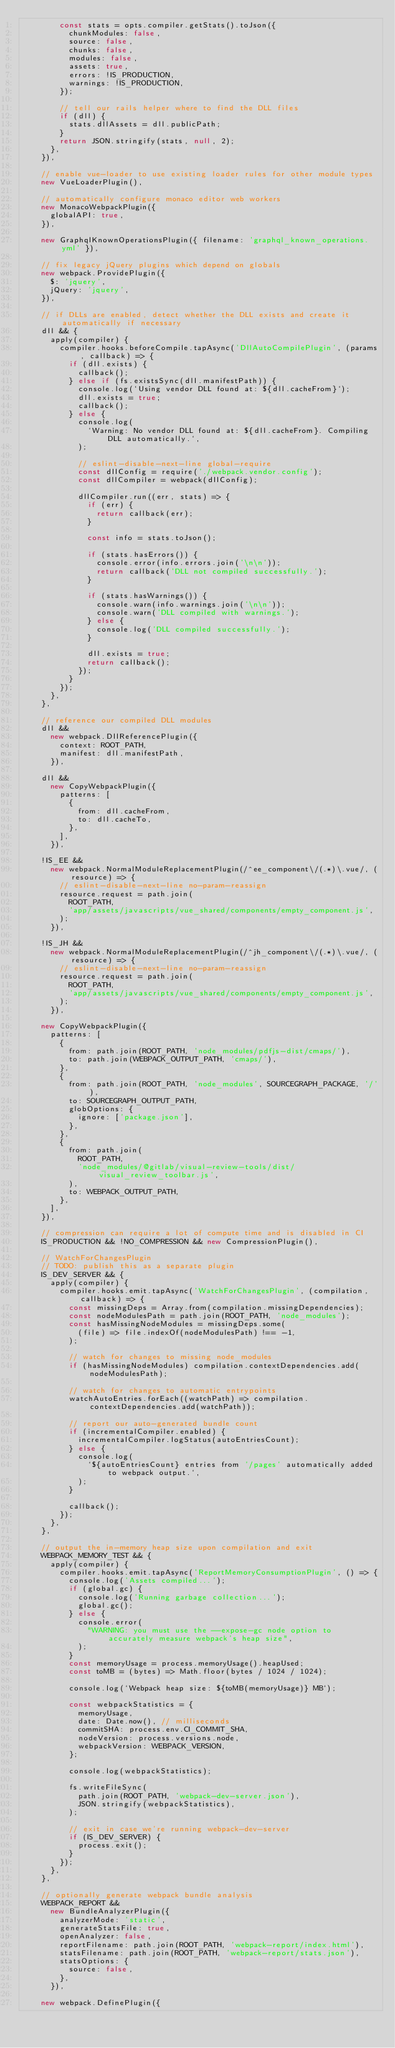Convert code to text. <code><loc_0><loc_0><loc_500><loc_500><_JavaScript_>        const stats = opts.compiler.getStats().toJson({
          chunkModules: false,
          source: false,
          chunks: false,
          modules: false,
          assets: true,
          errors: !IS_PRODUCTION,
          warnings: !IS_PRODUCTION,
        });

        // tell our rails helper where to find the DLL files
        if (dll) {
          stats.dllAssets = dll.publicPath;
        }
        return JSON.stringify(stats, null, 2);
      },
    }),

    // enable vue-loader to use existing loader rules for other module types
    new VueLoaderPlugin(),

    // automatically configure monaco editor web workers
    new MonacoWebpackPlugin({
      globalAPI: true,
    }),

    new GraphqlKnownOperationsPlugin({ filename: 'graphql_known_operations.yml' }),

    // fix legacy jQuery plugins which depend on globals
    new webpack.ProvidePlugin({
      $: 'jquery',
      jQuery: 'jquery',
    }),

    // if DLLs are enabled, detect whether the DLL exists and create it automatically if necessary
    dll && {
      apply(compiler) {
        compiler.hooks.beforeCompile.tapAsync('DllAutoCompilePlugin', (params, callback) => {
          if (dll.exists) {
            callback();
          } else if (fs.existsSync(dll.manifestPath)) {
            console.log(`Using vendor DLL found at: ${dll.cacheFrom}`);
            dll.exists = true;
            callback();
          } else {
            console.log(
              `Warning: No vendor DLL found at: ${dll.cacheFrom}. Compiling DLL automatically.`,
            );

            // eslint-disable-next-line global-require
            const dllConfig = require('./webpack.vendor.config');
            const dllCompiler = webpack(dllConfig);

            dllCompiler.run((err, stats) => {
              if (err) {
                return callback(err);
              }

              const info = stats.toJson();

              if (stats.hasErrors()) {
                console.error(info.errors.join('\n\n'));
                return callback('DLL not compiled successfully.');
              }

              if (stats.hasWarnings()) {
                console.warn(info.warnings.join('\n\n'));
                console.warn('DLL compiled with warnings.');
              } else {
                console.log('DLL compiled successfully.');
              }

              dll.exists = true;
              return callback();
            });
          }
        });
      },
    },

    // reference our compiled DLL modules
    dll &&
      new webpack.DllReferencePlugin({
        context: ROOT_PATH,
        manifest: dll.manifestPath,
      }),

    dll &&
      new CopyWebpackPlugin({
        patterns: [
          {
            from: dll.cacheFrom,
            to: dll.cacheTo,
          },
        ],
      }),

    !IS_EE &&
      new webpack.NormalModuleReplacementPlugin(/^ee_component\/(.*)\.vue/, (resource) => {
        // eslint-disable-next-line no-param-reassign
        resource.request = path.join(
          ROOT_PATH,
          'app/assets/javascripts/vue_shared/components/empty_component.js',
        );
      }),

    !IS_JH &&
      new webpack.NormalModuleReplacementPlugin(/^jh_component\/(.*)\.vue/, (resource) => {
        // eslint-disable-next-line no-param-reassign
        resource.request = path.join(
          ROOT_PATH,
          'app/assets/javascripts/vue_shared/components/empty_component.js',
        );
      }),

    new CopyWebpackPlugin({
      patterns: [
        {
          from: path.join(ROOT_PATH, 'node_modules/pdfjs-dist/cmaps/'),
          to: path.join(WEBPACK_OUTPUT_PATH, 'cmaps/'),
        },
        {
          from: path.join(ROOT_PATH, 'node_modules', SOURCEGRAPH_PACKAGE, '/'),
          to: SOURCEGRAPH_OUTPUT_PATH,
          globOptions: {
            ignore: ['package.json'],
          },
        },
        {
          from: path.join(
            ROOT_PATH,
            'node_modules/@gitlab/visual-review-tools/dist/visual_review_toolbar.js',
          ),
          to: WEBPACK_OUTPUT_PATH,
        },
      ],
    }),

    // compression can require a lot of compute time and is disabled in CI
    IS_PRODUCTION && !NO_COMPRESSION && new CompressionPlugin(),

    // WatchForChangesPlugin
    // TODO: publish this as a separate plugin
    IS_DEV_SERVER && {
      apply(compiler) {
        compiler.hooks.emit.tapAsync('WatchForChangesPlugin', (compilation, callback) => {
          const missingDeps = Array.from(compilation.missingDependencies);
          const nodeModulesPath = path.join(ROOT_PATH, 'node_modules');
          const hasMissingNodeModules = missingDeps.some(
            (file) => file.indexOf(nodeModulesPath) !== -1,
          );

          // watch for changes to missing node_modules
          if (hasMissingNodeModules) compilation.contextDependencies.add(nodeModulesPath);

          // watch for changes to automatic entrypoints
          watchAutoEntries.forEach((watchPath) => compilation.contextDependencies.add(watchPath));

          // report our auto-generated bundle count
          if (incrementalCompiler.enabled) {
            incrementalCompiler.logStatus(autoEntriesCount);
          } else {
            console.log(
              `${autoEntriesCount} entries from '/pages' automatically added to webpack output.`,
            );
          }

          callback();
        });
      },
    },

    // output the in-memory heap size upon compilation and exit
    WEBPACK_MEMORY_TEST && {
      apply(compiler) {
        compiler.hooks.emit.tapAsync('ReportMemoryConsumptionPlugin', () => {
          console.log('Assets compiled...');
          if (global.gc) {
            console.log('Running garbage collection...');
            global.gc();
          } else {
            console.error(
              "WARNING: you must use the --expose-gc node option to accurately measure webpack's heap size",
            );
          }
          const memoryUsage = process.memoryUsage().heapUsed;
          const toMB = (bytes) => Math.floor(bytes / 1024 / 1024);

          console.log(`Webpack heap size: ${toMB(memoryUsage)} MB`);

          const webpackStatistics = {
            memoryUsage,
            date: Date.now(), // milliseconds
            commitSHA: process.env.CI_COMMIT_SHA,
            nodeVersion: process.versions.node,
            webpackVersion: WEBPACK_VERSION,
          };

          console.log(webpackStatistics);

          fs.writeFileSync(
            path.join(ROOT_PATH, 'webpack-dev-server.json'),
            JSON.stringify(webpackStatistics),
          );

          // exit in case we're running webpack-dev-server
          if (IS_DEV_SERVER) {
            process.exit();
          }
        });
      },
    },

    // optionally generate webpack bundle analysis
    WEBPACK_REPORT &&
      new BundleAnalyzerPlugin({
        analyzerMode: 'static',
        generateStatsFile: true,
        openAnalyzer: false,
        reportFilename: path.join(ROOT_PATH, 'webpack-report/index.html'),
        statsFilename: path.join(ROOT_PATH, 'webpack-report/stats.json'),
        statsOptions: {
          source: false,
        },
      }),

    new webpack.DefinePlugin({</code> 